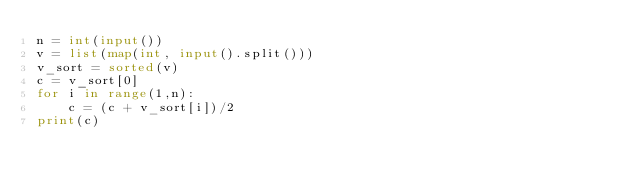<code> <loc_0><loc_0><loc_500><loc_500><_Python_>n = int(input())
v = list(map(int, input().split()))
v_sort = sorted(v)
c = v_sort[0]
for i in range(1,n):
    c = (c + v_sort[i])/2
print(c)</code> 